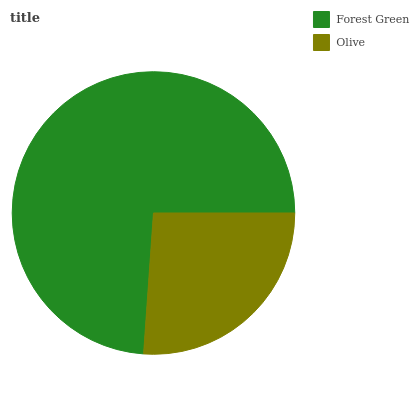Is Olive the minimum?
Answer yes or no. Yes. Is Forest Green the maximum?
Answer yes or no. Yes. Is Olive the maximum?
Answer yes or no. No. Is Forest Green greater than Olive?
Answer yes or no. Yes. Is Olive less than Forest Green?
Answer yes or no. Yes. Is Olive greater than Forest Green?
Answer yes or no. No. Is Forest Green less than Olive?
Answer yes or no. No. Is Forest Green the high median?
Answer yes or no. Yes. Is Olive the low median?
Answer yes or no. Yes. Is Olive the high median?
Answer yes or no. No. Is Forest Green the low median?
Answer yes or no. No. 